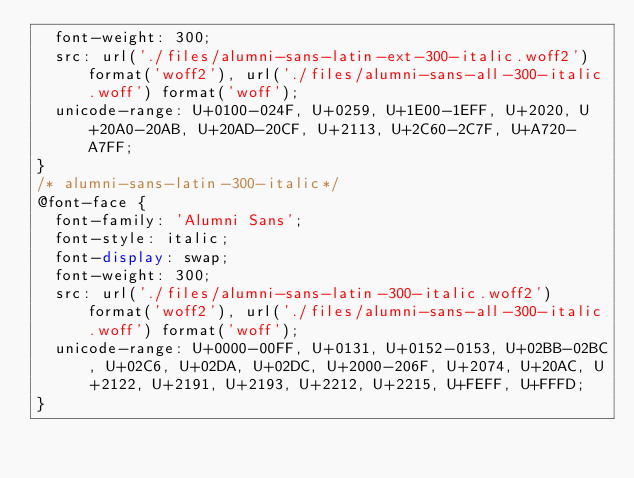<code> <loc_0><loc_0><loc_500><loc_500><_CSS_>  font-weight: 300;
  src: url('./files/alumni-sans-latin-ext-300-italic.woff2') format('woff2'), url('./files/alumni-sans-all-300-italic.woff') format('woff');
  unicode-range: U+0100-024F, U+0259, U+1E00-1EFF, U+2020, U+20A0-20AB, U+20AD-20CF, U+2113, U+2C60-2C7F, U+A720-A7FF;
}
/* alumni-sans-latin-300-italic*/
@font-face {
  font-family: 'Alumni Sans';
  font-style: italic;
  font-display: swap;
  font-weight: 300;
  src: url('./files/alumni-sans-latin-300-italic.woff2') format('woff2'), url('./files/alumni-sans-all-300-italic.woff') format('woff');
  unicode-range: U+0000-00FF, U+0131, U+0152-0153, U+02BB-02BC, U+02C6, U+02DA, U+02DC, U+2000-206F, U+2074, U+20AC, U+2122, U+2191, U+2193, U+2212, U+2215, U+FEFF, U+FFFD;
}
</code> 